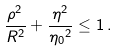Convert formula to latex. <formula><loc_0><loc_0><loc_500><loc_500>\frac { \rho ^ { 2 } } { R ^ { 2 } } + \frac { \eta ^ { 2 } } { { \eta _ { 0 } } ^ { 2 } } \leq 1 \, .</formula> 